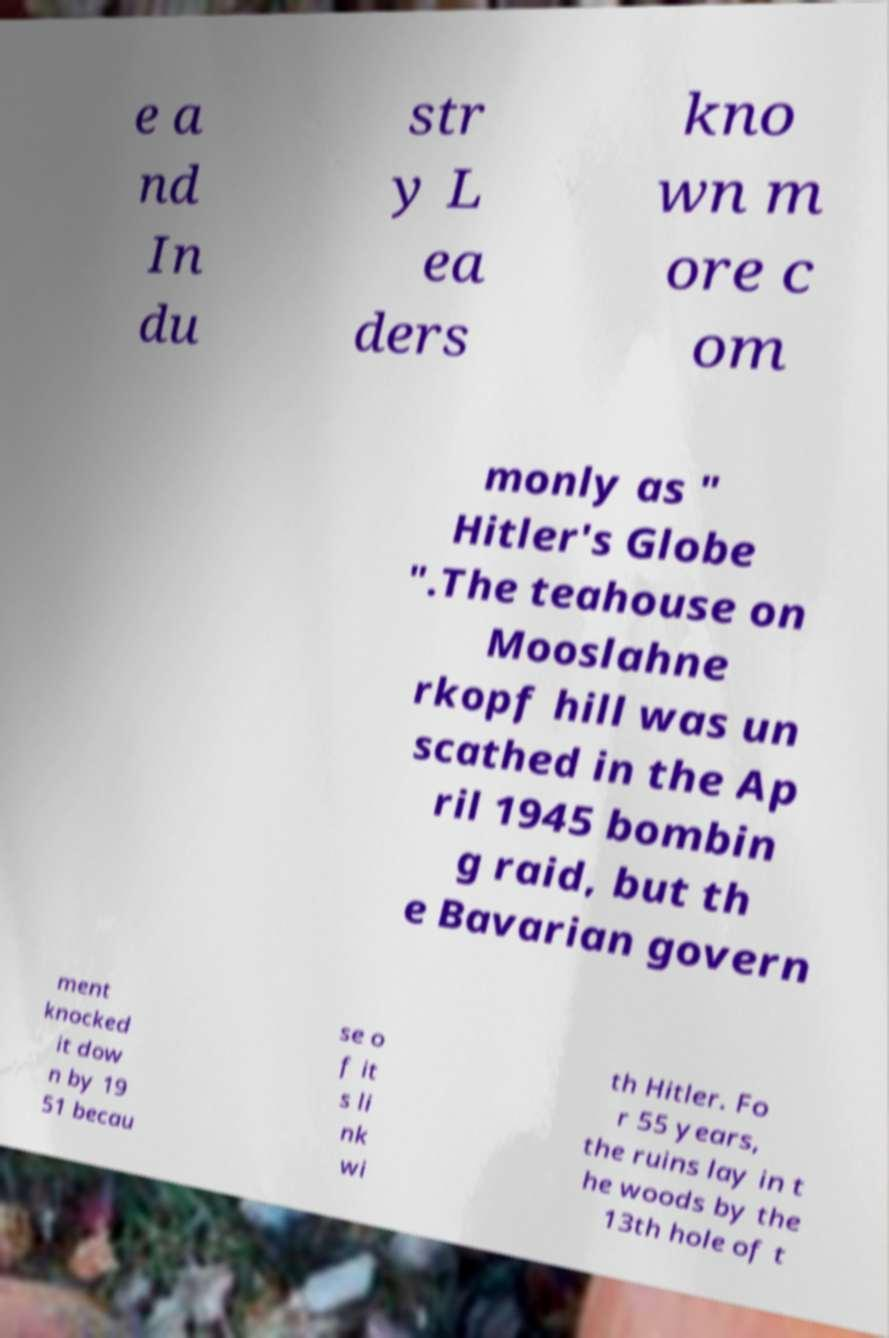For documentation purposes, I need the text within this image transcribed. Could you provide that? e a nd In du str y L ea ders kno wn m ore c om monly as " Hitler's Globe ".The teahouse on Mooslahne rkopf hill was un scathed in the Ap ril 1945 bombin g raid, but th e Bavarian govern ment knocked it dow n by 19 51 becau se o f it s li nk wi th Hitler. Fo r 55 years, the ruins lay in t he woods by the 13th hole of t 